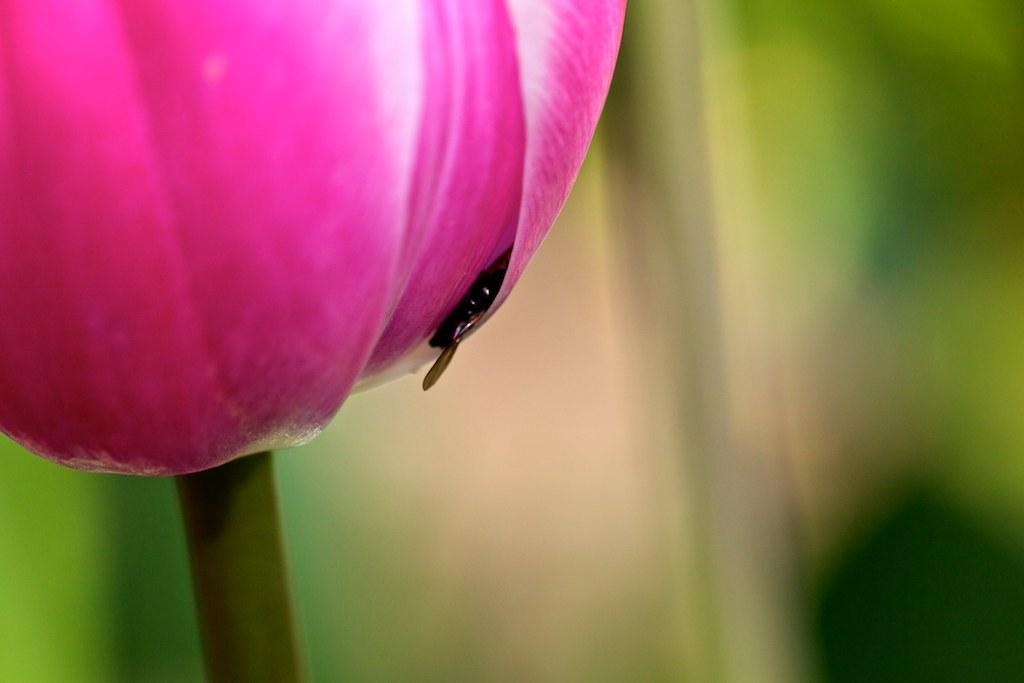What is the main subject of the image? There is a flower in the image. Are there any other living organisms present in the image? Yes, there is an insect in the image. How would you describe the background of the image? The background of the image is blurry. What type of letter can be seen in the image? There is no letter present in the image; it features a flower and an insect. How does the flower express its feelings of hate towards the insect in the image? The flower does not express any feelings of hate in the image, as it is an inanimate object and cannot have emotions. 